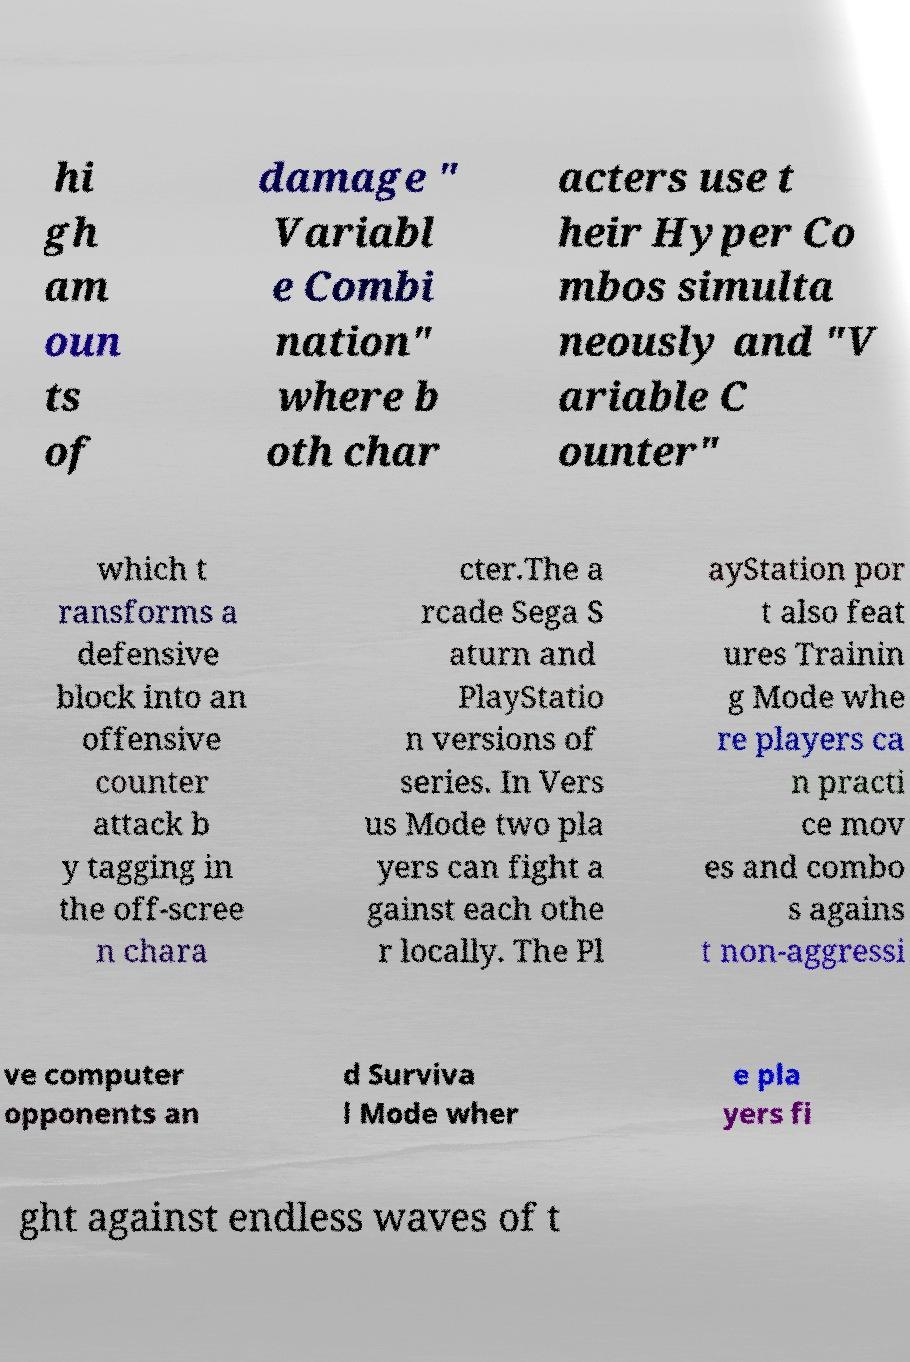What messages or text are displayed in this image? I need them in a readable, typed format. hi gh am oun ts of damage " Variabl e Combi nation" where b oth char acters use t heir Hyper Co mbos simulta neously and "V ariable C ounter" which t ransforms a defensive block into an offensive counter attack b y tagging in the off-scree n chara cter.The a rcade Sega S aturn and PlayStatio n versions of series. In Vers us Mode two pla yers can fight a gainst each othe r locally. The Pl ayStation por t also feat ures Trainin g Mode whe re players ca n practi ce mov es and combo s agains t non-aggressi ve computer opponents an d Surviva l Mode wher e pla yers fi ght against endless waves of t 